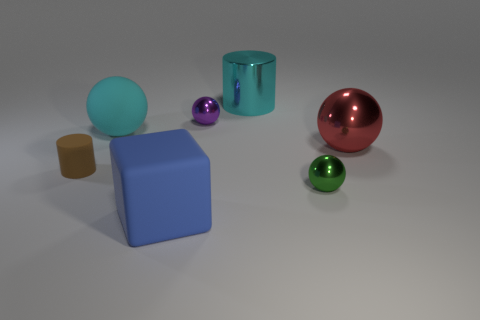There is a object that is the same color as the matte ball; what is its material?
Offer a terse response. Metal. Do the cyan rubber object and the big red shiny object have the same shape?
Provide a short and direct response. Yes. What is the shape of the big cyan object that is in front of the big metal thing that is behind the big red sphere?
Ensure brevity in your answer.  Sphere. Is there a tiny cyan matte ball?
Provide a short and direct response. No. How many cyan rubber objects are on the left side of the object that is left of the big cyan ball on the right side of the tiny brown matte object?
Your answer should be compact. 0. Do the red thing and the cyan thing that is left of the large metal cylinder have the same shape?
Provide a short and direct response. Yes. Are there more purple spheres than tiny purple cylinders?
Provide a short and direct response. Yes. There is a large cyan thing that is behind the tiny purple object; is it the same shape as the large red metallic object?
Provide a short and direct response. No. Is the number of big blue things behind the purple shiny sphere greater than the number of tiny red metallic things?
Provide a short and direct response. No. What is the color of the tiny shiny object in front of the big object that is on the right side of the green metallic object?
Offer a very short reply. Green. 